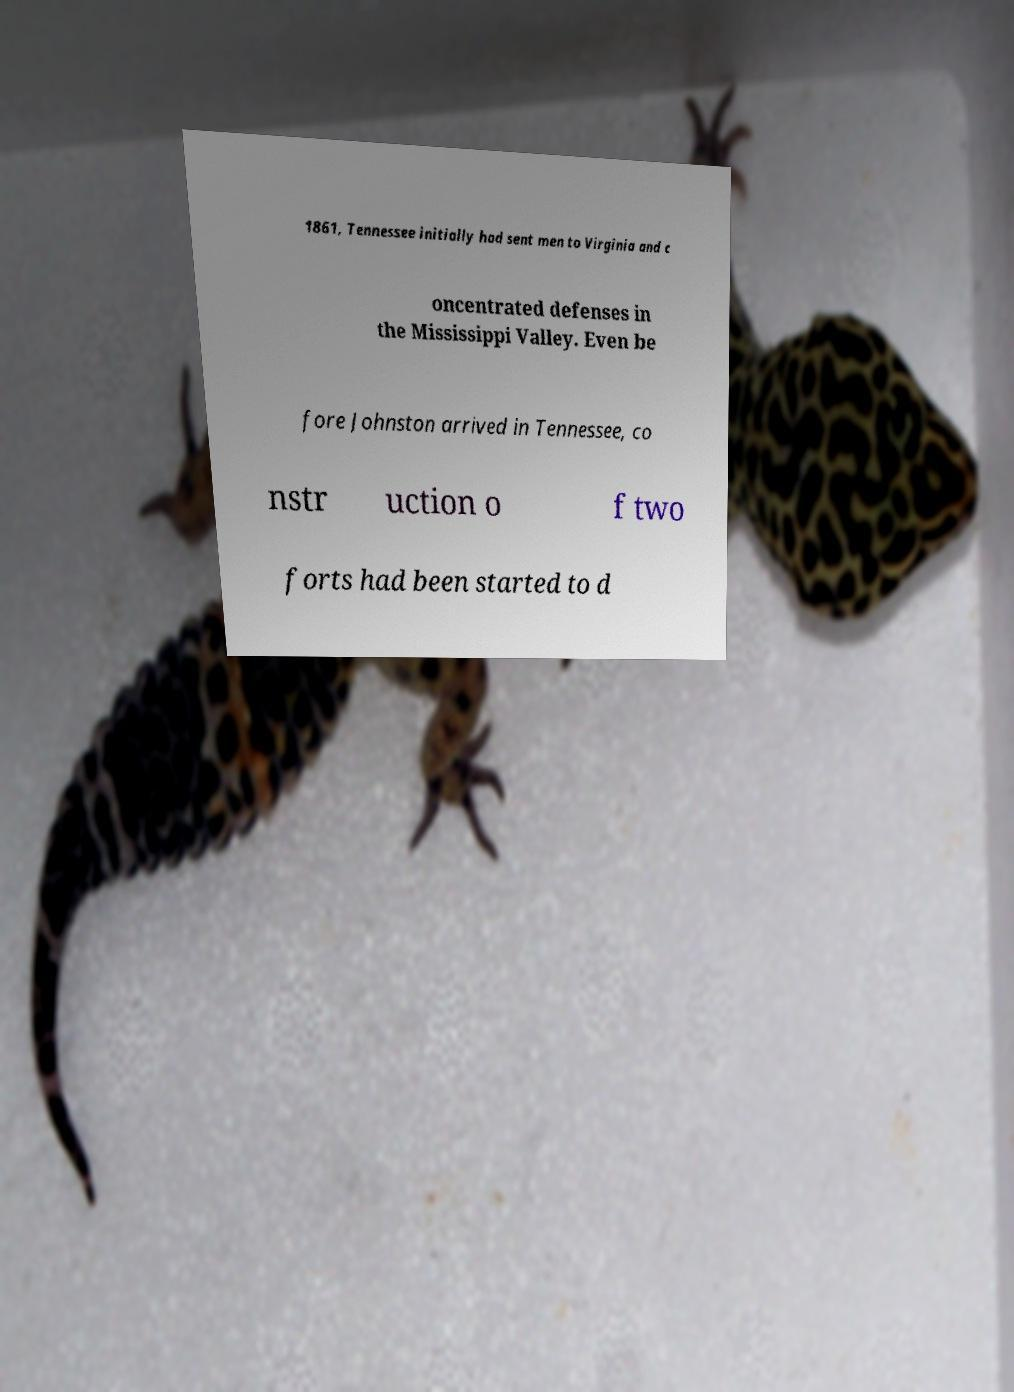For documentation purposes, I need the text within this image transcribed. Could you provide that? 1861, Tennessee initially had sent men to Virginia and c oncentrated defenses in the Mississippi Valley. Even be fore Johnston arrived in Tennessee, co nstr uction o f two forts had been started to d 